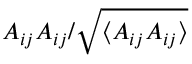<formula> <loc_0><loc_0><loc_500><loc_500>A _ { i j } A _ { i j } / \sqrt { \langle A _ { i j } A _ { i j } \rangle }</formula> 